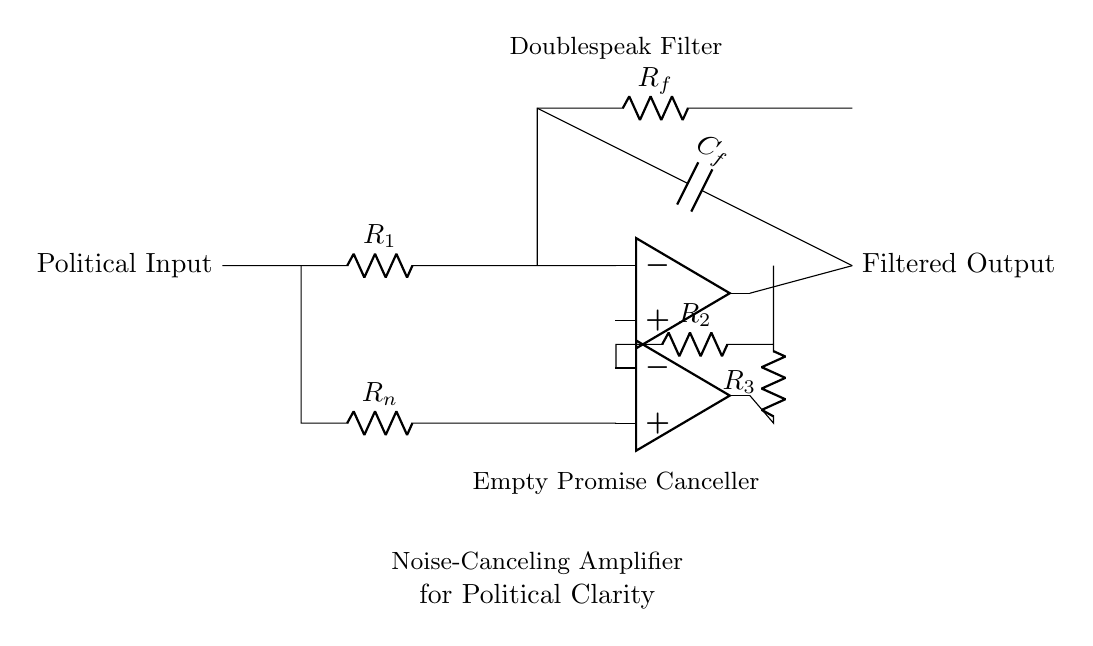What is the purpose of the capacitor in this circuit? The capacitor labeled C_f is used for feedback in the amplifier, allowing it to filter out high-frequency noise while stabilizing the gain for the input signal.
Answer: Feedback What component is used to cancel noise in this circuit? The resistor R_n is specifically designated in the circuit for noise cancellation, working alongside the operational amplifier to reduce unwanted signals, representing political doublespeak.
Answer: Resistor How many operational amplifiers are present in this circuit? The circuit contains two operational amplifiers, which are crucial for processing the input signal and providing the necessary amplification and filtering to clarify the output.
Answer: Two What are the two main functionalities shown in this amplifier circuit? The circuit serves two unique purposes: filtering out doublespeak and cancelling empty promises, demonstrated by the specific labeling of each section within the circuit.
Answer: Filtering and Cancelling What component is used for feedback in this amplifier circuit? The resistor labeled R_f connects back from the output to the input of the first operational amplifier to control the gain, indicating its vital role in the feedback mechanism.
Answer: Resistor What is the role of R_1 in this amplifier circuit? Resistor R_1 is part of the input stage that influences the input current and voltage relationship, crucial for establishing the conditions for amplification in the circuit.
Answer: Input resistor 